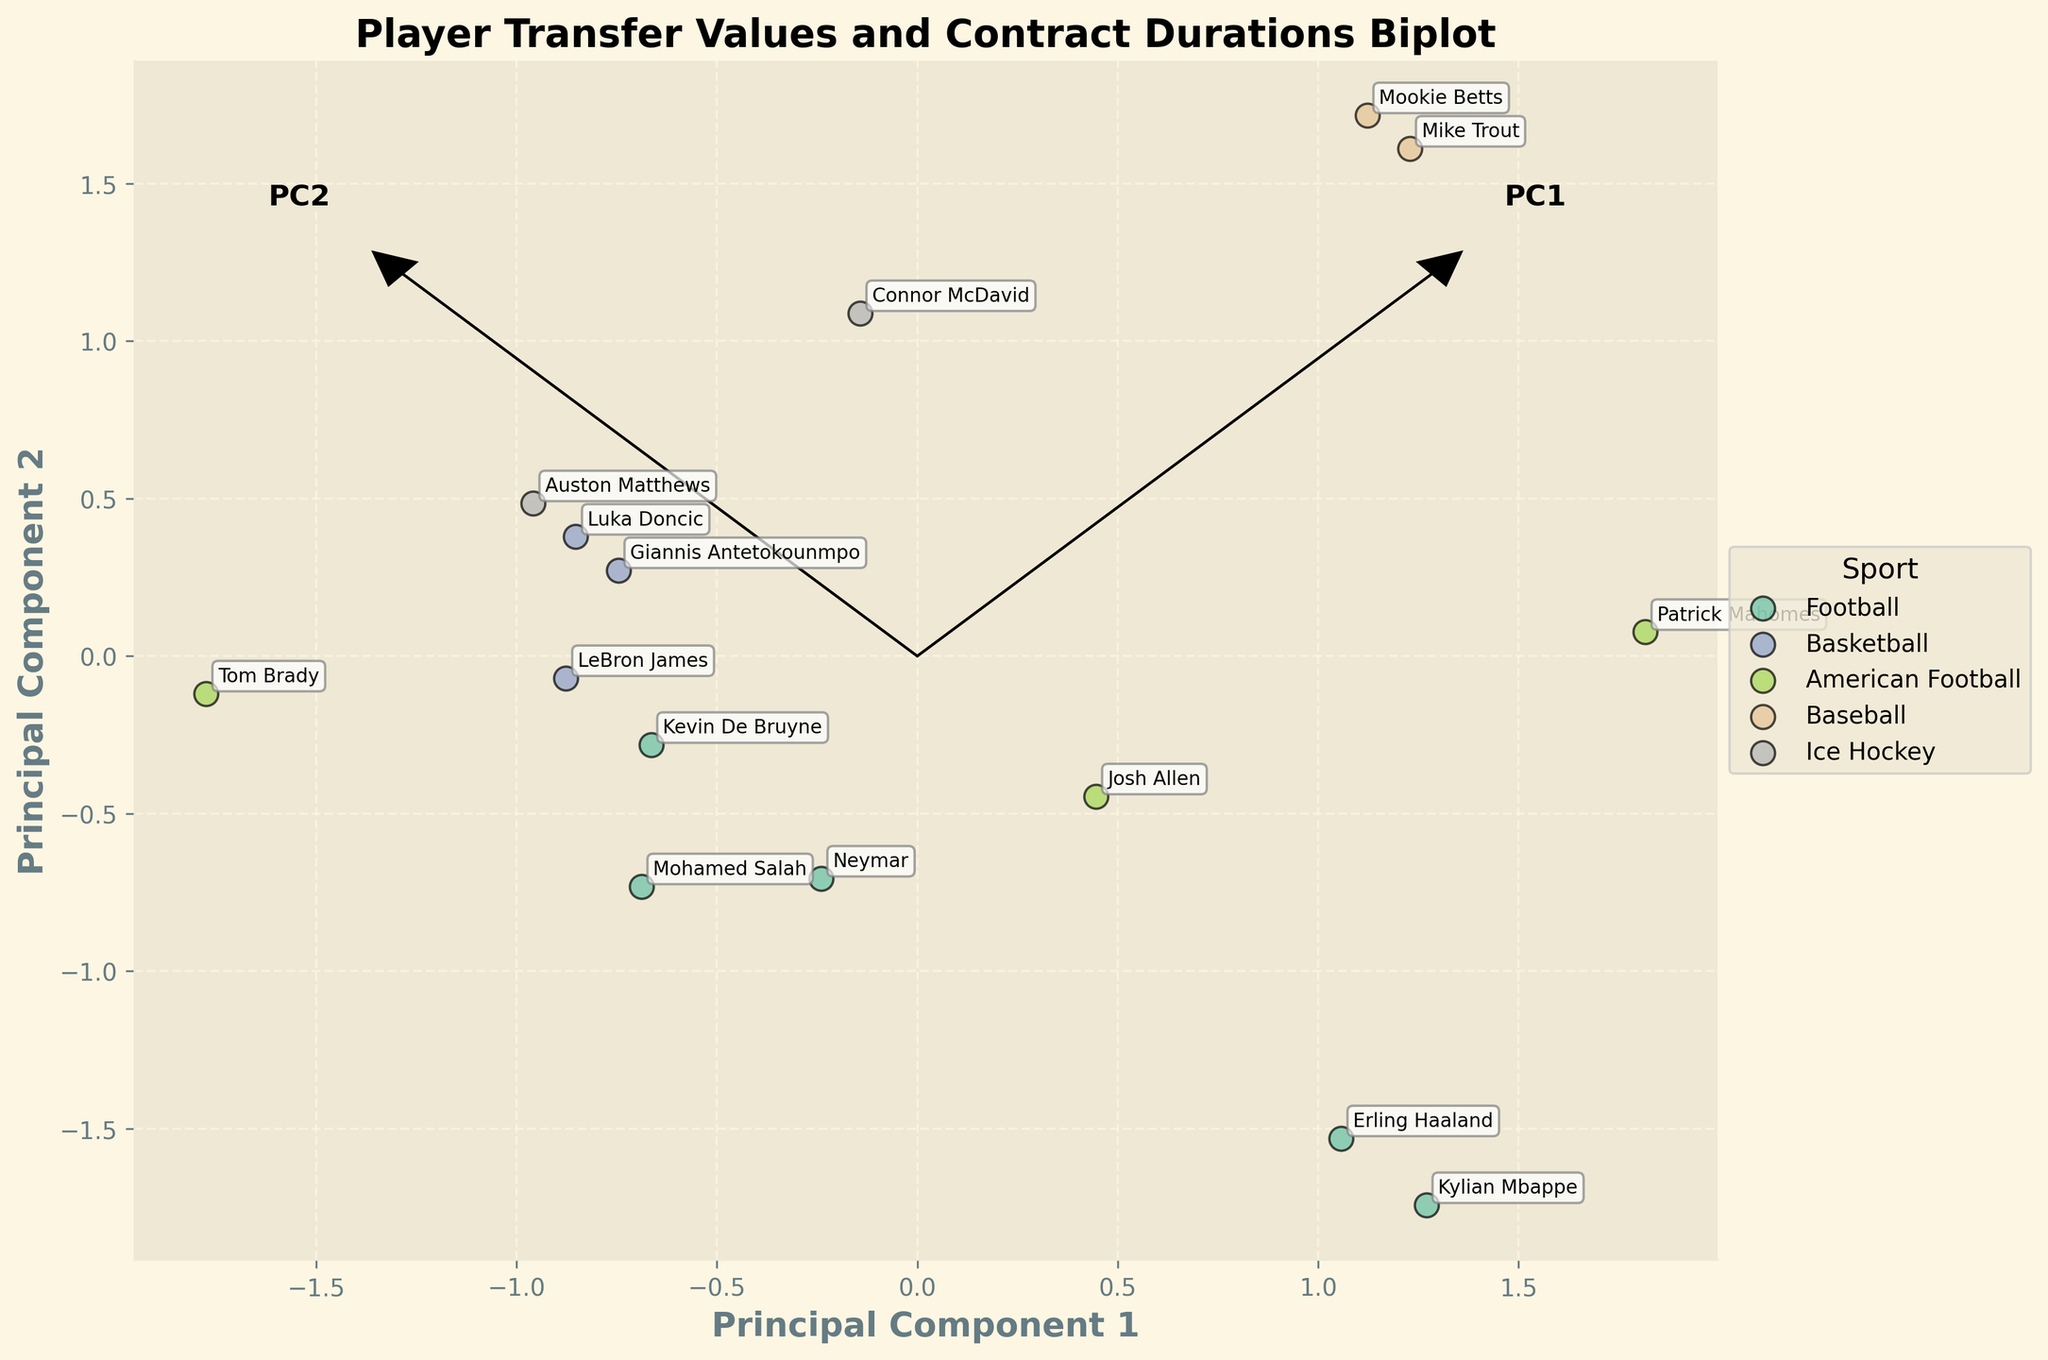How many sports are represented in the biplot? Count the unique colors in the legend that represent different sports. There are six unique colors for Football, Basketball, American Football, Baseball, Ice Hockey, and Ligue 1.
Answer: 6 Which player has the longest contract duration? Identify the player annotated closest to the top-right corner along the Contract_Duration_Years axis. Mike Trout has the highest Contract Duration of 12 years.
Answer: Mike Trout What is the relationship between Transfer Value and Contract Duration? Observe the direction of the eigenvector arrows and data spread. Players with longer contract durations typically have higher transfer values, indicated by the general upward-right spread of data points and eigenvectors.
Answer: Positive correlation Which sport tends to have the lowest transfer values? Look for the cluster of points representing the sport closest to the bottom-left region of the plot. Ice Hockey, represented by generally lower and leftward points like Connor McDavid, tends to have the lowest transfer values.
Answer: Ice Hockey Which players from Football (Premier League) have similar Contract Duration and Transfer Value? Identify and compare the positions of annotated players of Football(Premier League) to find those close to each other. Erling Haaland and Kevin De Bruyne are closely positioned and have similar Contract Duration(5 years) and high Transfer Value(170M, 100M).
Answer: Erling Haaland, Kevin De Bruyne What does the arrow direction of PC1 indicate? Examine the direction and length of the PC1 arrow with respect to the data points and transfer value scale. The PC1 arrow indicates higher Transfer Values moving to the right since it's aligned with players like Mike Trout and Kylian Mbappe.
Answer: Higher Transfer Value Compare the contract durations between Basketball players. Annotate and compare the y-coordinates of data points labeled with Basketball player names. LeBron James, Luka Doncic, and Giannis Antetokounmpo each have varying contract durations of 4, 5, and 5 years, respectively.
Answer: 4 to 5 years Which player has the shortest contract duration, and what is their transfer value? Find the annotation closest to the bottom-left of the plot. Tom Brady, with a Contract Duration of 2 years, has a Transfer Value of 70 million.
Answer: Tom Brady (70 million) Which Principal Component contributes more to explaining Transfer Value? Assess the alignment of eigenvector arrows with the transfer value axis. PC1 arrow is more aligned with the horizontal axis and thus contributes more to explaining Transfer Value variations.
Answer: PC1 